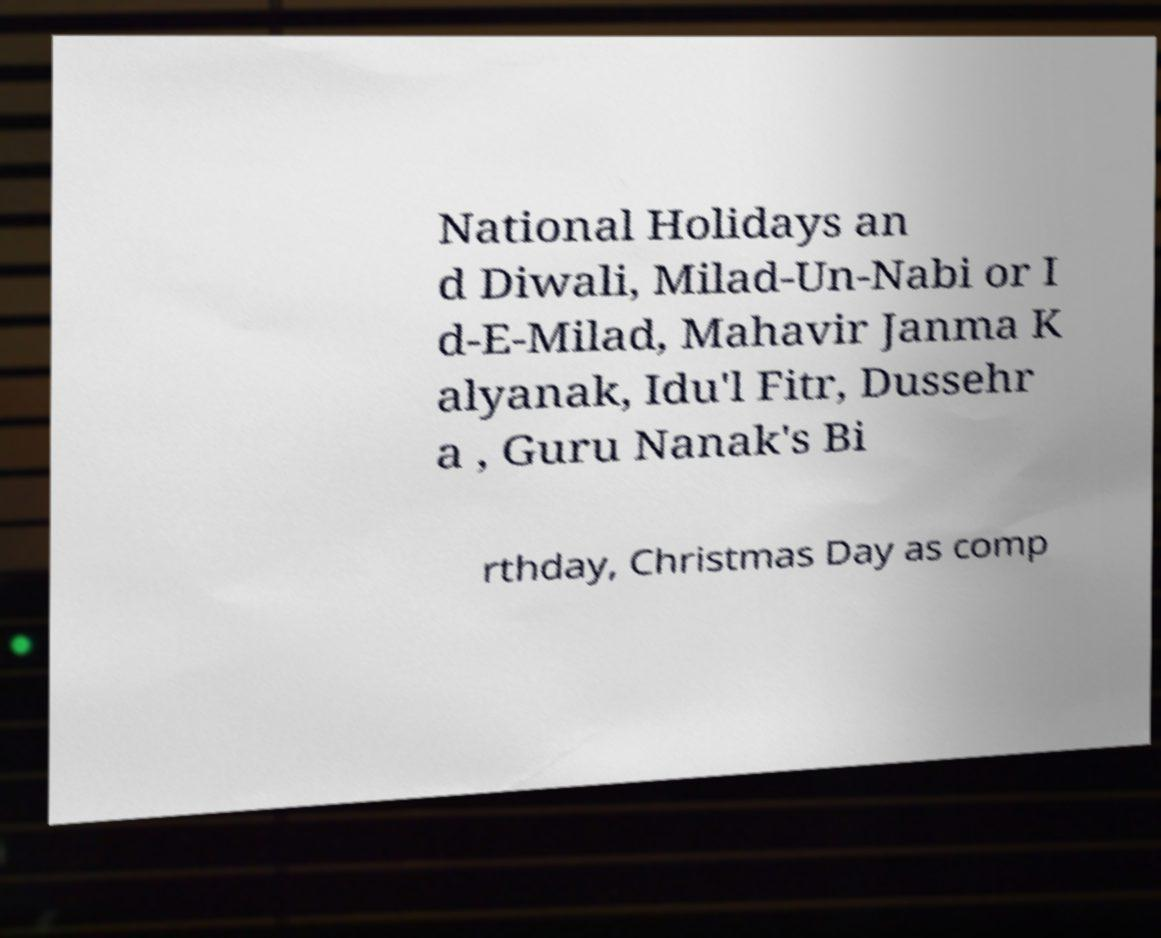Can you accurately transcribe the text from the provided image for me? National Holidays an d Diwali, Milad-Un-Nabi or I d-E-Milad, Mahavir Janma K alyanak, Idu'l Fitr, Dussehr a , Guru Nanak's Bi rthday, Christmas Day as comp 